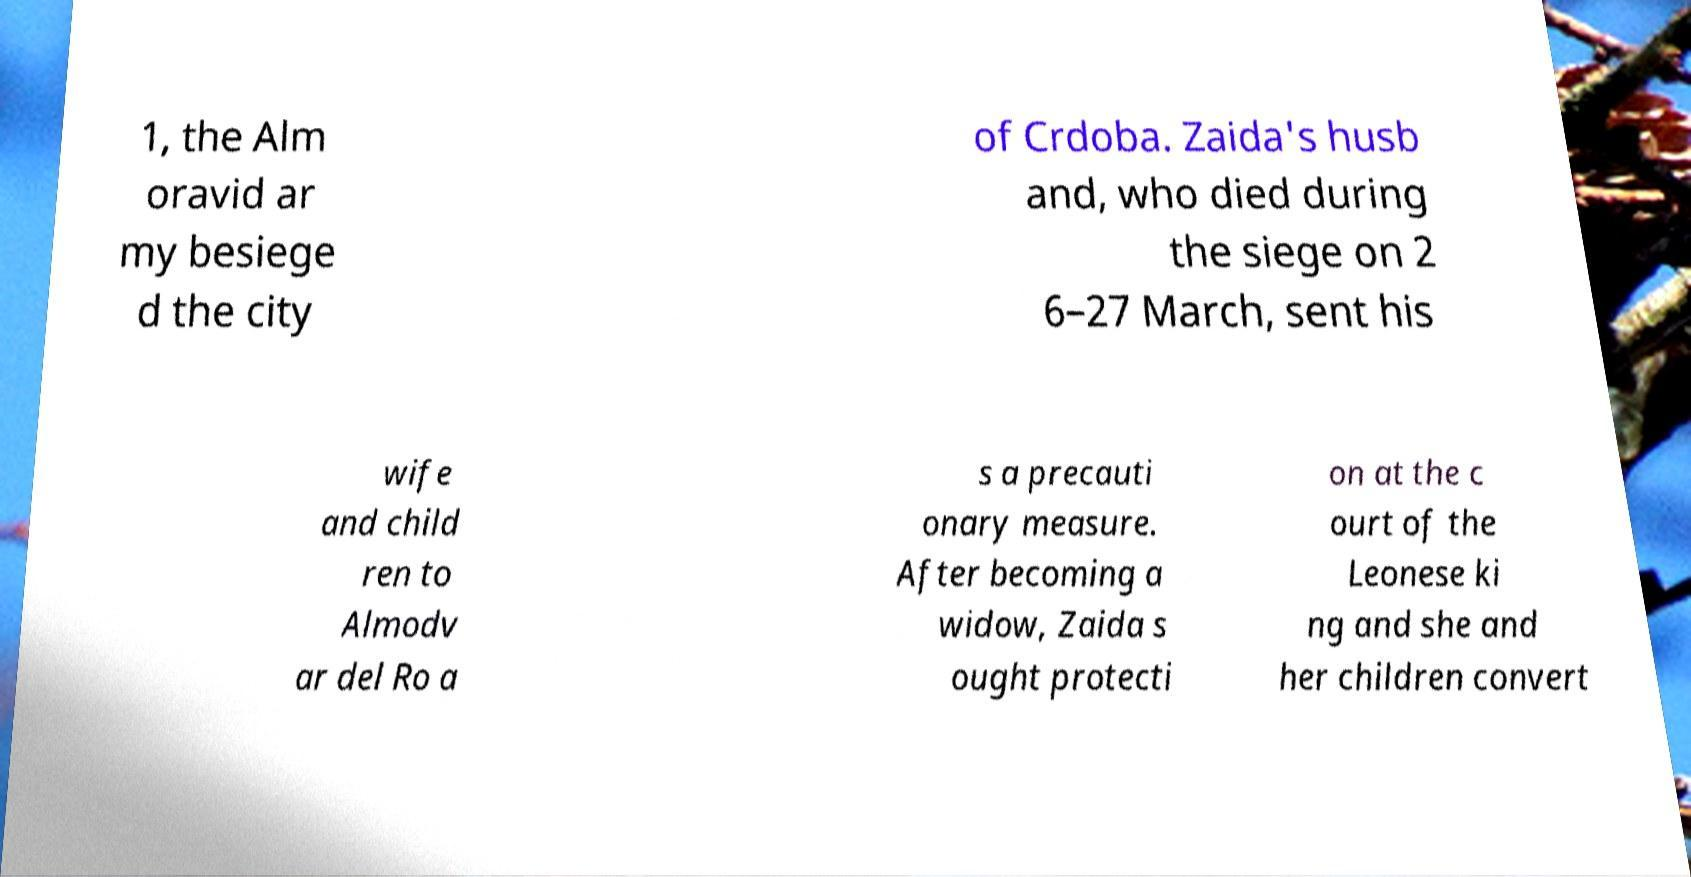Can you read and provide the text displayed in the image?This photo seems to have some interesting text. Can you extract and type it out for me? 1, the Alm oravid ar my besiege d the city of Crdoba. Zaida's husb and, who died during the siege on 2 6–27 March, sent his wife and child ren to Almodv ar del Ro a s a precauti onary measure. After becoming a widow, Zaida s ought protecti on at the c ourt of the Leonese ki ng and she and her children convert 